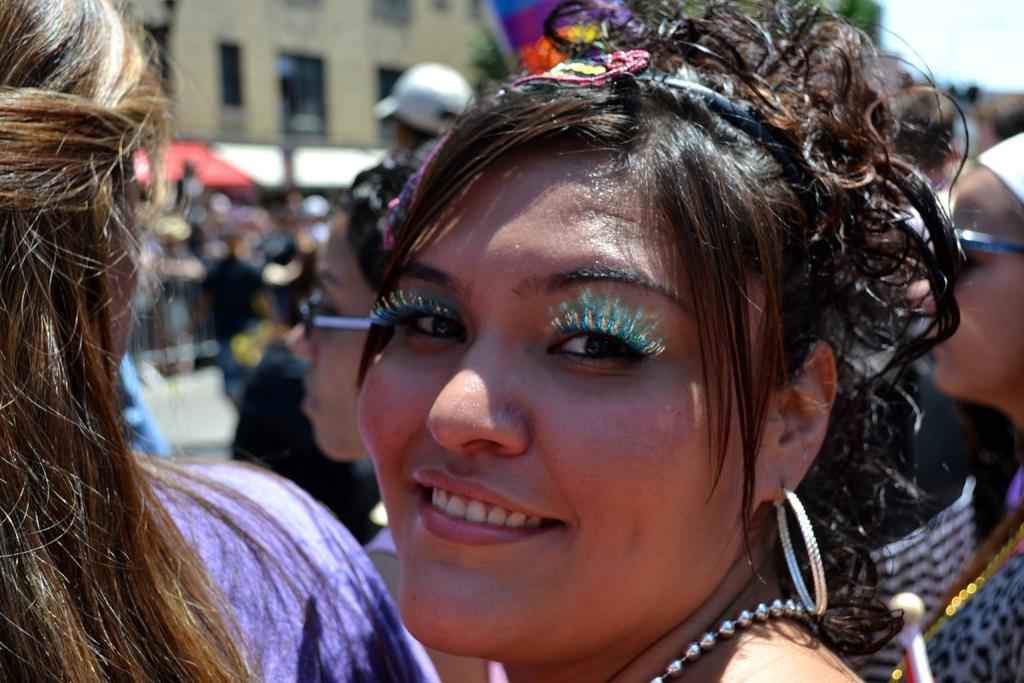How many people are in the image? There are people in the image, but the exact number is not specified. What is located in the background of the image? There is a building in the background of the image. What is visible in the sky in the image? The sky is visible in the background of the image. What type of nail is being used to produce the point in the image? There is no nail or point being depicted in the image. 